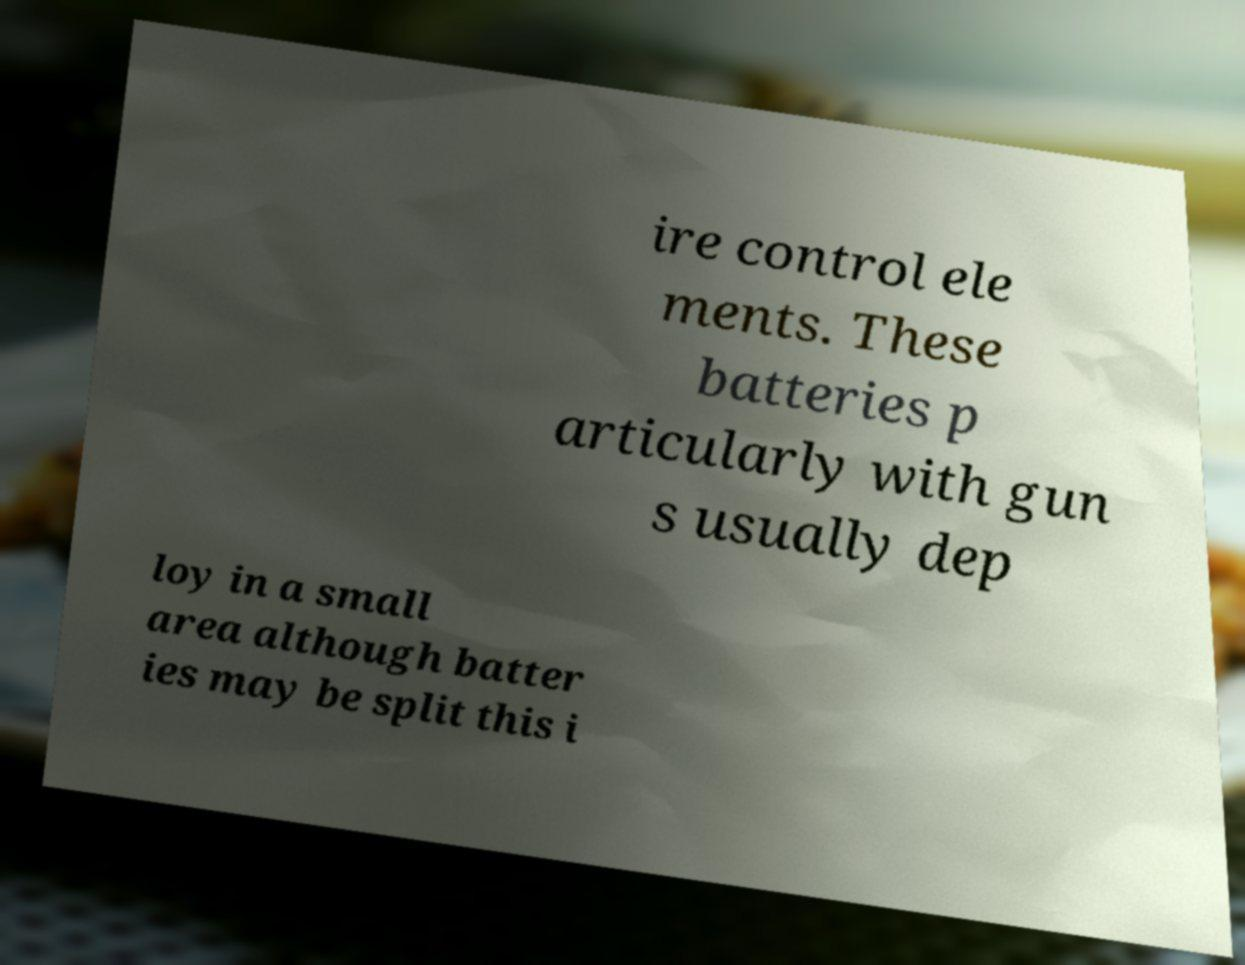Can you read and provide the text displayed in the image?This photo seems to have some interesting text. Can you extract and type it out for me? ire control ele ments. These batteries p articularly with gun s usually dep loy in a small area although batter ies may be split this i 